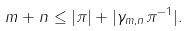<formula> <loc_0><loc_0><loc_500><loc_500>m + n \leq | \pi | + | \gamma _ { m , n } \pi ^ { - 1 } | .</formula> 